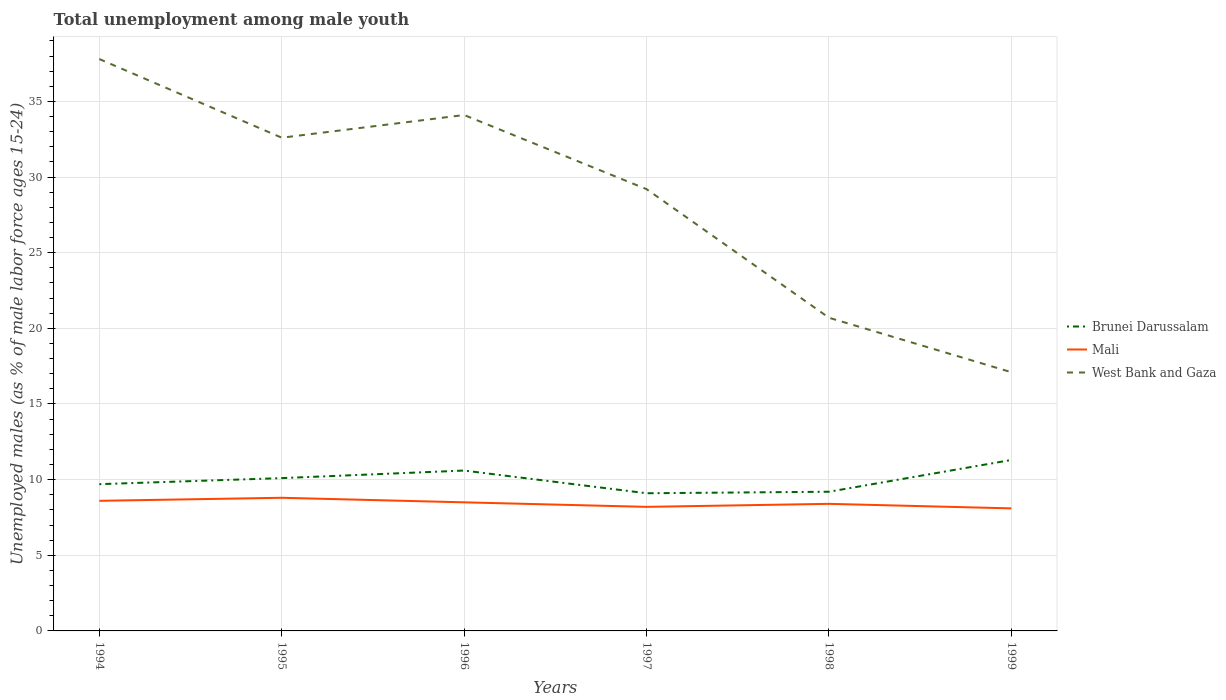How many different coloured lines are there?
Offer a terse response. 3. Across all years, what is the maximum percentage of unemployed males in in West Bank and Gaza?
Offer a terse response. 17.1. What is the total percentage of unemployed males in in Brunei Darussalam in the graph?
Offer a terse response. -2.1. What is the difference between the highest and the second highest percentage of unemployed males in in West Bank and Gaza?
Ensure brevity in your answer.  20.7. What is the difference between the highest and the lowest percentage of unemployed males in in Mali?
Offer a terse response. 3. How many lines are there?
Give a very brief answer. 3. What is the difference between two consecutive major ticks on the Y-axis?
Make the answer very short. 5. Does the graph contain any zero values?
Your answer should be very brief. No. Where does the legend appear in the graph?
Your answer should be very brief. Center right. What is the title of the graph?
Keep it short and to the point. Total unemployment among male youth. What is the label or title of the Y-axis?
Provide a succinct answer. Unemployed males (as % of male labor force ages 15-24). What is the Unemployed males (as % of male labor force ages 15-24) in Brunei Darussalam in 1994?
Offer a very short reply. 9.7. What is the Unemployed males (as % of male labor force ages 15-24) in Mali in 1994?
Your answer should be compact. 8.6. What is the Unemployed males (as % of male labor force ages 15-24) of West Bank and Gaza in 1994?
Provide a succinct answer. 37.8. What is the Unemployed males (as % of male labor force ages 15-24) of Brunei Darussalam in 1995?
Give a very brief answer. 10.1. What is the Unemployed males (as % of male labor force ages 15-24) of Mali in 1995?
Your answer should be compact. 8.8. What is the Unemployed males (as % of male labor force ages 15-24) of West Bank and Gaza in 1995?
Your response must be concise. 32.6. What is the Unemployed males (as % of male labor force ages 15-24) of Brunei Darussalam in 1996?
Provide a short and direct response. 10.6. What is the Unemployed males (as % of male labor force ages 15-24) of Mali in 1996?
Provide a short and direct response. 8.5. What is the Unemployed males (as % of male labor force ages 15-24) of West Bank and Gaza in 1996?
Provide a short and direct response. 34.1. What is the Unemployed males (as % of male labor force ages 15-24) of Brunei Darussalam in 1997?
Offer a very short reply. 9.1. What is the Unemployed males (as % of male labor force ages 15-24) of Mali in 1997?
Keep it short and to the point. 8.2. What is the Unemployed males (as % of male labor force ages 15-24) of West Bank and Gaza in 1997?
Offer a terse response. 29.2. What is the Unemployed males (as % of male labor force ages 15-24) in Brunei Darussalam in 1998?
Make the answer very short. 9.2. What is the Unemployed males (as % of male labor force ages 15-24) of Mali in 1998?
Your response must be concise. 8.4. What is the Unemployed males (as % of male labor force ages 15-24) in West Bank and Gaza in 1998?
Provide a short and direct response. 20.7. What is the Unemployed males (as % of male labor force ages 15-24) in Brunei Darussalam in 1999?
Keep it short and to the point. 11.3. What is the Unemployed males (as % of male labor force ages 15-24) of Mali in 1999?
Provide a succinct answer. 8.1. What is the Unemployed males (as % of male labor force ages 15-24) of West Bank and Gaza in 1999?
Your answer should be very brief. 17.1. Across all years, what is the maximum Unemployed males (as % of male labor force ages 15-24) in Brunei Darussalam?
Give a very brief answer. 11.3. Across all years, what is the maximum Unemployed males (as % of male labor force ages 15-24) of Mali?
Ensure brevity in your answer.  8.8. Across all years, what is the maximum Unemployed males (as % of male labor force ages 15-24) in West Bank and Gaza?
Provide a succinct answer. 37.8. Across all years, what is the minimum Unemployed males (as % of male labor force ages 15-24) in Brunei Darussalam?
Provide a short and direct response. 9.1. Across all years, what is the minimum Unemployed males (as % of male labor force ages 15-24) in Mali?
Provide a succinct answer. 8.1. Across all years, what is the minimum Unemployed males (as % of male labor force ages 15-24) in West Bank and Gaza?
Offer a very short reply. 17.1. What is the total Unemployed males (as % of male labor force ages 15-24) of Mali in the graph?
Ensure brevity in your answer.  50.6. What is the total Unemployed males (as % of male labor force ages 15-24) of West Bank and Gaza in the graph?
Give a very brief answer. 171.5. What is the difference between the Unemployed males (as % of male labor force ages 15-24) of Mali in 1994 and that in 1995?
Ensure brevity in your answer.  -0.2. What is the difference between the Unemployed males (as % of male labor force ages 15-24) in West Bank and Gaza in 1994 and that in 1995?
Provide a short and direct response. 5.2. What is the difference between the Unemployed males (as % of male labor force ages 15-24) in Brunei Darussalam in 1994 and that in 1996?
Offer a very short reply. -0.9. What is the difference between the Unemployed males (as % of male labor force ages 15-24) of Mali in 1994 and that in 1996?
Provide a short and direct response. 0.1. What is the difference between the Unemployed males (as % of male labor force ages 15-24) in Mali in 1994 and that in 1997?
Your answer should be very brief. 0.4. What is the difference between the Unemployed males (as % of male labor force ages 15-24) of Brunei Darussalam in 1994 and that in 1998?
Make the answer very short. 0.5. What is the difference between the Unemployed males (as % of male labor force ages 15-24) in Mali in 1994 and that in 1998?
Your answer should be very brief. 0.2. What is the difference between the Unemployed males (as % of male labor force ages 15-24) in Brunei Darussalam in 1994 and that in 1999?
Provide a short and direct response. -1.6. What is the difference between the Unemployed males (as % of male labor force ages 15-24) of West Bank and Gaza in 1994 and that in 1999?
Your answer should be compact. 20.7. What is the difference between the Unemployed males (as % of male labor force ages 15-24) of Mali in 1995 and that in 1996?
Provide a succinct answer. 0.3. What is the difference between the Unemployed males (as % of male labor force ages 15-24) of West Bank and Gaza in 1995 and that in 1997?
Offer a very short reply. 3.4. What is the difference between the Unemployed males (as % of male labor force ages 15-24) in West Bank and Gaza in 1995 and that in 1998?
Provide a short and direct response. 11.9. What is the difference between the Unemployed males (as % of male labor force ages 15-24) of Brunei Darussalam in 1995 and that in 1999?
Your response must be concise. -1.2. What is the difference between the Unemployed males (as % of male labor force ages 15-24) in Mali in 1995 and that in 1999?
Keep it short and to the point. 0.7. What is the difference between the Unemployed males (as % of male labor force ages 15-24) in West Bank and Gaza in 1995 and that in 1999?
Your answer should be compact. 15.5. What is the difference between the Unemployed males (as % of male labor force ages 15-24) of Brunei Darussalam in 1996 and that in 1997?
Ensure brevity in your answer.  1.5. What is the difference between the Unemployed males (as % of male labor force ages 15-24) in Mali in 1996 and that in 1997?
Provide a short and direct response. 0.3. What is the difference between the Unemployed males (as % of male labor force ages 15-24) of West Bank and Gaza in 1996 and that in 1997?
Keep it short and to the point. 4.9. What is the difference between the Unemployed males (as % of male labor force ages 15-24) in Mali in 1996 and that in 1998?
Your answer should be compact. 0.1. What is the difference between the Unemployed males (as % of male labor force ages 15-24) of Mali in 1996 and that in 1999?
Give a very brief answer. 0.4. What is the difference between the Unemployed males (as % of male labor force ages 15-24) of West Bank and Gaza in 1996 and that in 1999?
Provide a short and direct response. 17. What is the difference between the Unemployed males (as % of male labor force ages 15-24) in Mali in 1997 and that in 1998?
Your response must be concise. -0.2. What is the difference between the Unemployed males (as % of male labor force ages 15-24) of West Bank and Gaza in 1997 and that in 1998?
Your answer should be compact. 8.5. What is the difference between the Unemployed males (as % of male labor force ages 15-24) in Brunei Darussalam in 1997 and that in 1999?
Provide a succinct answer. -2.2. What is the difference between the Unemployed males (as % of male labor force ages 15-24) in Mali in 1997 and that in 1999?
Offer a terse response. 0.1. What is the difference between the Unemployed males (as % of male labor force ages 15-24) in West Bank and Gaza in 1998 and that in 1999?
Your answer should be compact. 3.6. What is the difference between the Unemployed males (as % of male labor force ages 15-24) in Brunei Darussalam in 1994 and the Unemployed males (as % of male labor force ages 15-24) in Mali in 1995?
Your answer should be compact. 0.9. What is the difference between the Unemployed males (as % of male labor force ages 15-24) of Brunei Darussalam in 1994 and the Unemployed males (as % of male labor force ages 15-24) of West Bank and Gaza in 1995?
Keep it short and to the point. -22.9. What is the difference between the Unemployed males (as % of male labor force ages 15-24) in Brunei Darussalam in 1994 and the Unemployed males (as % of male labor force ages 15-24) in West Bank and Gaza in 1996?
Your answer should be compact. -24.4. What is the difference between the Unemployed males (as % of male labor force ages 15-24) of Mali in 1994 and the Unemployed males (as % of male labor force ages 15-24) of West Bank and Gaza in 1996?
Make the answer very short. -25.5. What is the difference between the Unemployed males (as % of male labor force ages 15-24) of Brunei Darussalam in 1994 and the Unemployed males (as % of male labor force ages 15-24) of West Bank and Gaza in 1997?
Keep it short and to the point. -19.5. What is the difference between the Unemployed males (as % of male labor force ages 15-24) of Mali in 1994 and the Unemployed males (as % of male labor force ages 15-24) of West Bank and Gaza in 1997?
Give a very brief answer. -20.6. What is the difference between the Unemployed males (as % of male labor force ages 15-24) of Brunei Darussalam in 1994 and the Unemployed males (as % of male labor force ages 15-24) of Mali in 1998?
Provide a short and direct response. 1.3. What is the difference between the Unemployed males (as % of male labor force ages 15-24) of Brunei Darussalam in 1994 and the Unemployed males (as % of male labor force ages 15-24) of West Bank and Gaza in 1998?
Ensure brevity in your answer.  -11. What is the difference between the Unemployed males (as % of male labor force ages 15-24) of Brunei Darussalam in 1994 and the Unemployed males (as % of male labor force ages 15-24) of Mali in 1999?
Make the answer very short. 1.6. What is the difference between the Unemployed males (as % of male labor force ages 15-24) of Brunei Darussalam in 1994 and the Unemployed males (as % of male labor force ages 15-24) of West Bank and Gaza in 1999?
Offer a terse response. -7.4. What is the difference between the Unemployed males (as % of male labor force ages 15-24) of Mali in 1994 and the Unemployed males (as % of male labor force ages 15-24) of West Bank and Gaza in 1999?
Provide a short and direct response. -8.5. What is the difference between the Unemployed males (as % of male labor force ages 15-24) in Brunei Darussalam in 1995 and the Unemployed males (as % of male labor force ages 15-24) in Mali in 1996?
Your response must be concise. 1.6. What is the difference between the Unemployed males (as % of male labor force ages 15-24) in Brunei Darussalam in 1995 and the Unemployed males (as % of male labor force ages 15-24) in West Bank and Gaza in 1996?
Your answer should be very brief. -24. What is the difference between the Unemployed males (as % of male labor force ages 15-24) in Mali in 1995 and the Unemployed males (as % of male labor force ages 15-24) in West Bank and Gaza in 1996?
Provide a short and direct response. -25.3. What is the difference between the Unemployed males (as % of male labor force ages 15-24) in Brunei Darussalam in 1995 and the Unemployed males (as % of male labor force ages 15-24) in Mali in 1997?
Ensure brevity in your answer.  1.9. What is the difference between the Unemployed males (as % of male labor force ages 15-24) of Brunei Darussalam in 1995 and the Unemployed males (as % of male labor force ages 15-24) of West Bank and Gaza in 1997?
Keep it short and to the point. -19.1. What is the difference between the Unemployed males (as % of male labor force ages 15-24) in Mali in 1995 and the Unemployed males (as % of male labor force ages 15-24) in West Bank and Gaza in 1997?
Offer a very short reply. -20.4. What is the difference between the Unemployed males (as % of male labor force ages 15-24) of Brunei Darussalam in 1995 and the Unemployed males (as % of male labor force ages 15-24) of West Bank and Gaza in 1998?
Make the answer very short. -10.6. What is the difference between the Unemployed males (as % of male labor force ages 15-24) in Brunei Darussalam in 1995 and the Unemployed males (as % of male labor force ages 15-24) in West Bank and Gaza in 1999?
Give a very brief answer. -7. What is the difference between the Unemployed males (as % of male labor force ages 15-24) in Mali in 1995 and the Unemployed males (as % of male labor force ages 15-24) in West Bank and Gaza in 1999?
Ensure brevity in your answer.  -8.3. What is the difference between the Unemployed males (as % of male labor force ages 15-24) in Brunei Darussalam in 1996 and the Unemployed males (as % of male labor force ages 15-24) in West Bank and Gaza in 1997?
Keep it short and to the point. -18.6. What is the difference between the Unemployed males (as % of male labor force ages 15-24) of Mali in 1996 and the Unemployed males (as % of male labor force ages 15-24) of West Bank and Gaza in 1997?
Give a very brief answer. -20.7. What is the difference between the Unemployed males (as % of male labor force ages 15-24) in Brunei Darussalam in 1996 and the Unemployed males (as % of male labor force ages 15-24) in Mali in 1998?
Offer a very short reply. 2.2. What is the difference between the Unemployed males (as % of male labor force ages 15-24) of Brunei Darussalam in 1996 and the Unemployed males (as % of male labor force ages 15-24) of West Bank and Gaza in 1998?
Make the answer very short. -10.1. What is the difference between the Unemployed males (as % of male labor force ages 15-24) of Mali in 1996 and the Unemployed males (as % of male labor force ages 15-24) of West Bank and Gaza in 1999?
Ensure brevity in your answer.  -8.6. What is the difference between the Unemployed males (as % of male labor force ages 15-24) in Mali in 1997 and the Unemployed males (as % of male labor force ages 15-24) in West Bank and Gaza in 1998?
Keep it short and to the point. -12.5. What is the difference between the Unemployed males (as % of male labor force ages 15-24) of Brunei Darussalam in 1997 and the Unemployed males (as % of male labor force ages 15-24) of Mali in 1999?
Your answer should be compact. 1. What is the difference between the Unemployed males (as % of male labor force ages 15-24) of Brunei Darussalam in 1997 and the Unemployed males (as % of male labor force ages 15-24) of West Bank and Gaza in 1999?
Your answer should be very brief. -8. What is the difference between the Unemployed males (as % of male labor force ages 15-24) in Mali in 1997 and the Unemployed males (as % of male labor force ages 15-24) in West Bank and Gaza in 1999?
Offer a terse response. -8.9. What is the difference between the Unemployed males (as % of male labor force ages 15-24) in Brunei Darussalam in 1998 and the Unemployed males (as % of male labor force ages 15-24) in Mali in 1999?
Make the answer very short. 1.1. What is the difference between the Unemployed males (as % of male labor force ages 15-24) of Brunei Darussalam in 1998 and the Unemployed males (as % of male labor force ages 15-24) of West Bank and Gaza in 1999?
Ensure brevity in your answer.  -7.9. What is the difference between the Unemployed males (as % of male labor force ages 15-24) of Mali in 1998 and the Unemployed males (as % of male labor force ages 15-24) of West Bank and Gaza in 1999?
Offer a very short reply. -8.7. What is the average Unemployed males (as % of male labor force ages 15-24) in Mali per year?
Give a very brief answer. 8.43. What is the average Unemployed males (as % of male labor force ages 15-24) of West Bank and Gaza per year?
Offer a terse response. 28.58. In the year 1994, what is the difference between the Unemployed males (as % of male labor force ages 15-24) of Brunei Darussalam and Unemployed males (as % of male labor force ages 15-24) of West Bank and Gaza?
Keep it short and to the point. -28.1. In the year 1994, what is the difference between the Unemployed males (as % of male labor force ages 15-24) in Mali and Unemployed males (as % of male labor force ages 15-24) in West Bank and Gaza?
Your answer should be very brief. -29.2. In the year 1995, what is the difference between the Unemployed males (as % of male labor force ages 15-24) of Brunei Darussalam and Unemployed males (as % of male labor force ages 15-24) of West Bank and Gaza?
Offer a very short reply. -22.5. In the year 1995, what is the difference between the Unemployed males (as % of male labor force ages 15-24) in Mali and Unemployed males (as % of male labor force ages 15-24) in West Bank and Gaza?
Your answer should be very brief. -23.8. In the year 1996, what is the difference between the Unemployed males (as % of male labor force ages 15-24) in Brunei Darussalam and Unemployed males (as % of male labor force ages 15-24) in West Bank and Gaza?
Provide a succinct answer. -23.5. In the year 1996, what is the difference between the Unemployed males (as % of male labor force ages 15-24) in Mali and Unemployed males (as % of male labor force ages 15-24) in West Bank and Gaza?
Offer a very short reply. -25.6. In the year 1997, what is the difference between the Unemployed males (as % of male labor force ages 15-24) of Brunei Darussalam and Unemployed males (as % of male labor force ages 15-24) of West Bank and Gaza?
Keep it short and to the point. -20.1. In the year 1998, what is the difference between the Unemployed males (as % of male labor force ages 15-24) in Brunei Darussalam and Unemployed males (as % of male labor force ages 15-24) in West Bank and Gaza?
Provide a short and direct response. -11.5. What is the ratio of the Unemployed males (as % of male labor force ages 15-24) in Brunei Darussalam in 1994 to that in 1995?
Your response must be concise. 0.96. What is the ratio of the Unemployed males (as % of male labor force ages 15-24) in Mali in 1994 to that in 1995?
Your answer should be compact. 0.98. What is the ratio of the Unemployed males (as % of male labor force ages 15-24) in West Bank and Gaza in 1994 to that in 1995?
Provide a succinct answer. 1.16. What is the ratio of the Unemployed males (as % of male labor force ages 15-24) in Brunei Darussalam in 1994 to that in 1996?
Ensure brevity in your answer.  0.92. What is the ratio of the Unemployed males (as % of male labor force ages 15-24) in Mali in 1994 to that in 1996?
Provide a succinct answer. 1.01. What is the ratio of the Unemployed males (as % of male labor force ages 15-24) of West Bank and Gaza in 1994 to that in 1996?
Your answer should be compact. 1.11. What is the ratio of the Unemployed males (as % of male labor force ages 15-24) in Brunei Darussalam in 1994 to that in 1997?
Your response must be concise. 1.07. What is the ratio of the Unemployed males (as % of male labor force ages 15-24) in Mali in 1994 to that in 1997?
Provide a short and direct response. 1.05. What is the ratio of the Unemployed males (as % of male labor force ages 15-24) in West Bank and Gaza in 1994 to that in 1997?
Provide a short and direct response. 1.29. What is the ratio of the Unemployed males (as % of male labor force ages 15-24) of Brunei Darussalam in 1994 to that in 1998?
Keep it short and to the point. 1.05. What is the ratio of the Unemployed males (as % of male labor force ages 15-24) of Mali in 1994 to that in 1998?
Your answer should be compact. 1.02. What is the ratio of the Unemployed males (as % of male labor force ages 15-24) of West Bank and Gaza in 1994 to that in 1998?
Ensure brevity in your answer.  1.83. What is the ratio of the Unemployed males (as % of male labor force ages 15-24) of Brunei Darussalam in 1994 to that in 1999?
Offer a terse response. 0.86. What is the ratio of the Unemployed males (as % of male labor force ages 15-24) in Mali in 1994 to that in 1999?
Your response must be concise. 1.06. What is the ratio of the Unemployed males (as % of male labor force ages 15-24) in West Bank and Gaza in 1994 to that in 1999?
Make the answer very short. 2.21. What is the ratio of the Unemployed males (as % of male labor force ages 15-24) in Brunei Darussalam in 1995 to that in 1996?
Your answer should be compact. 0.95. What is the ratio of the Unemployed males (as % of male labor force ages 15-24) of Mali in 1995 to that in 1996?
Make the answer very short. 1.04. What is the ratio of the Unemployed males (as % of male labor force ages 15-24) of West Bank and Gaza in 1995 to that in 1996?
Offer a terse response. 0.96. What is the ratio of the Unemployed males (as % of male labor force ages 15-24) in Brunei Darussalam in 1995 to that in 1997?
Keep it short and to the point. 1.11. What is the ratio of the Unemployed males (as % of male labor force ages 15-24) in Mali in 1995 to that in 1997?
Provide a succinct answer. 1.07. What is the ratio of the Unemployed males (as % of male labor force ages 15-24) of West Bank and Gaza in 1995 to that in 1997?
Ensure brevity in your answer.  1.12. What is the ratio of the Unemployed males (as % of male labor force ages 15-24) in Brunei Darussalam in 1995 to that in 1998?
Your answer should be compact. 1.1. What is the ratio of the Unemployed males (as % of male labor force ages 15-24) in Mali in 1995 to that in 1998?
Offer a very short reply. 1.05. What is the ratio of the Unemployed males (as % of male labor force ages 15-24) in West Bank and Gaza in 1995 to that in 1998?
Your response must be concise. 1.57. What is the ratio of the Unemployed males (as % of male labor force ages 15-24) of Brunei Darussalam in 1995 to that in 1999?
Keep it short and to the point. 0.89. What is the ratio of the Unemployed males (as % of male labor force ages 15-24) in Mali in 1995 to that in 1999?
Offer a terse response. 1.09. What is the ratio of the Unemployed males (as % of male labor force ages 15-24) in West Bank and Gaza in 1995 to that in 1999?
Your answer should be very brief. 1.91. What is the ratio of the Unemployed males (as % of male labor force ages 15-24) of Brunei Darussalam in 1996 to that in 1997?
Provide a succinct answer. 1.16. What is the ratio of the Unemployed males (as % of male labor force ages 15-24) of Mali in 1996 to that in 1997?
Keep it short and to the point. 1.04. What is the ratio of the Unemployed males (as % of male labor force ages 15-24) of West Bank and Gaza in 1996 to that in 1997?
Ensure brevity in your answer.  1.17. What is the ratio of the Unemployed males (as % of male labor force ages 15-24) of Brunei Darussalam in 1996 to that in 1998?
Keep it short and to the point. 1.15. What is the ratio of the Unemployed males (as % of male labor force ages 15-24) in Mali in 1996 to that in 1998?
Offer a very short reply. 1.01. What is the ratio of the Unemployed males (as % of male labor force ages 15-24) in West Bank and Gaza in 1996 to that in 1998?
Your answer should be very brief. 1.65. What is the ratio of the Unemployed males (as % of male labor force ages 15-24) in Brunei Darussalam in 1996 to that in 1999?
Your response must be concise. 0.94. What is the ratio of the Unemployed males (as % of male labor force ages 15-24) of Mali in 1996 to that in 1999?
Provide a short and direct response. 1.05. What is the ratio of the Unemployed males (as % of male labor force ages 15-24) of West Bank and Gaza in 1996 to that in 1999?
Ensure brevity in your answer.  1.99. What is the ratio of the Unemployed males (as % of male labor force ages 15-24) of Mali in 1997 to that in 1998?
Your response must be concise. 0.98. What is the ratio of the Unemployed males (as % of male labor force ages 15-24) of West Bank and Gaza in 1997 to that in 1998?
Provide a succinct answer. 1.41. What is the ratio of the Unemployed males (as % of male labor force ages 15-24) in Brunei Darussalam in 1997 to that in 1999?
Your answer should be compact. 0.81. What is the ratio of the Unemployed males (as % of male labor force ages 15-24) of Mali in 1997 to that in 1999?
Your answer should be very brief. 1.01. What is the ratio of the Unemployed males (as % of male labor force ages 15-24) of West Bank and Gaza in 1997 to that in 1999?
Your answer should be compact. 1.71. What is the ratio of the Unemployed males (as % of male labor force ages 15-24) of Brunei Darussalam in 1998 to that in 1999?
Make the answer very short. 0.81. What is the ratio of the Unemployed males (as % of male labor force ages 15-24) of Mali in 1998 to that in 1999?
Provide a succinct answer. 1.04. What is the ratio of the Unemployed males (as % of male labor force ages 15-24) in West Bank and Gaza in 1998 to that in 1999?
Your answer should be very brief. 1.21. What is the difference between the highest and the second highest Unemployed males (as % of male labor force ages 15-24) of Mali?
Provide a short and direct response. 0.2. What is the difference between the highest and the second highest Unemployed males (as % of male labor force ages 15-24) in West Bank and Gaza?
Provide a short and direct response. 3.7. What is the difference between the highest and the lowest Unemployed males (as % of male labor force ages 15-24) in West Bank and Gaza?
Your response must be concise. 20.7. 